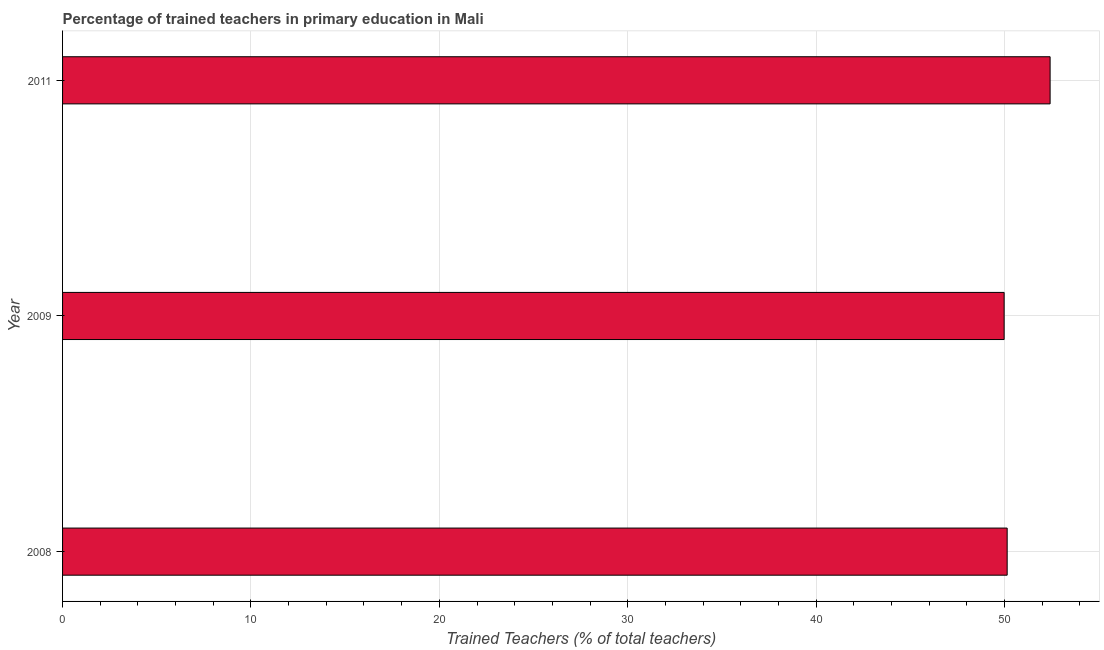Does the graph contain grids?
Offer a very short reply. Yes. What is the title of the graph?
Provide a succinct answer. Percentage of trained teachers in primary education in Mali. What is the label or title of the X-axis?
Your answer should be compact. Trained Teachers (% of total teachers). What is the label or title of the Y-axis?
Provide a short and direct response. Year. What is the percentage of trained teachers in 2009?
Your answer should be very brief. 49.98. Across all years, what is the maximum percentage of trained teachers?
Offer a very short reply. 52.42. Across all years, what is the minimum percentage of trained teachers?
Your answer should be compact. 49.98. What is the sum of the percentage of trained teachers?
Offer a very short reply. 152.55. What is the difference between the percentage of trained teachers in 2009 and 2011?
Give a very brief answer. -2.44. What is the average percentage of trained teachers per year?
Ensure brevity in your answer.  50.85. What is the median percentage of trained teachers?
Keep it short and to the point. 50.14. Is the percentage of trained teachers in 2008 less than that in 2011?
Ensure brevity in your answer.  Yes. What is the difference between the highest and the second highest percentage of trained teachers?
Give a very brief answer. 2.28. Is the sum of the percentage of trained teachers in 2008 and 2009 greater than the maximum percentage of trained teachers across all years?
Give a very brief answer. Yes. What is the difference between the highest and the lowest percentage of trained teachers?
Your answer should be very brief. 2.44. In how many years, is the percentage of trained teachers greater than the average percentage of trained teachers taken over all years?
Make the answer very short. 1. How many bars are there?
Make the answer very short. 3. Are all the bars in the graph horizontal?
Make the answer very short. Yes. How many years are there in the graph?
Offer a terse response. 3. Are the values on the major ticks of X-axis written in scientific E-notation?
Offer a very short reply. No. What is the Trained Teachers (% of total teachers) in 2008?
Your answer should be very brief. 50.14. What is the Trained Teachers (% of total teachers) in 2009?
Ensure brevity in your answer.  49.98. What is the Trained Teachers (% of total teachers) of 2011?
Provide a succinct answer. 52.42. What is the difference between the Trained Teachers (% of total teachers) in 2008 and 2009?
Your response must be concise. 0.16. What is the difference between the Trained Teachers (% of total teachers) in 2008 and 2011?
Your answer should be very brief. -2.28. What is the difference between the Trained Teachers (% of total teachers) in 2009 and 2011?
Your response must be concise. -2.44. What is the ratio of the Trained Teachers (% of total teachers) in 2009 to that in 2011?
Provide a succinct answer. 0.95. 